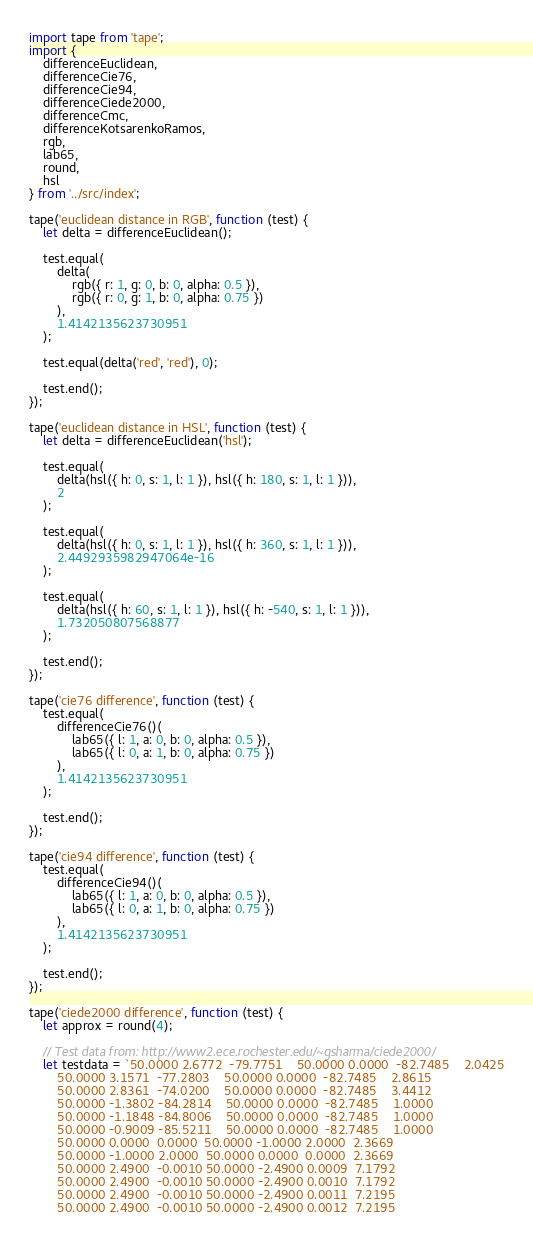Convert code to text. <code><loc_0><loc_0><loc_500><loc_500><_JavaScript_>import tape from 'tape';
import {
	differenceEuclidean,
	differenceCie76,
	differenceCie94,
	differenceCiede2000,
	differenceCmc,
	differenceKotsarenkoRamos,
	rgb,
	lab65,
	round,
	hsl
} from '../src/index';

tape('euclidean distance in RGB', function (test) {
	let delta = differenceEuclidean();

	test.equal(
		delta(
			rgb({ r: 1, g: 0, b: 0, alpha: 0.5 }),
			rgb({ r: 0, g: 1, b: 0, alpha: 0.75 })
		),
		1.4142135623730951
	);

	test.equal(delta('red', 'red'), 0);

	test.end();
});

tape('euclidean distance in HSL', function (test) {
	let delta = differenceEuclidean('hsl');

	test.equal(
		delta(hsl({ h: 0, s: 1, l: 1 }), hsl({ h: 180, s: 1, l: 1 })),
		2
	);

	test.equal(
		delta(hsl({ h: 0, s: 1, l: 1 }), hsl({ h: 360, s: 1, l: 1 })),
		2.4492935982947064e-16
	);

	test.equal(
		delta(hsl({ h: 60, s: 1, l: 1 }), hsl({ h: -540, s: 1, l: 1 })),
		1.732050807568877
	);

	test.end();
});

tape('cie76 difference', function (test) {
	test.equal(
		differenceCie76()(
			lab65({ l: 1, a: 0, b: 0, alpha: 0.5 }),
			lab65({ l: 0, a: 1, b: 0, alpha: 0.75 })
		),
		1.4142135623730951
	);

	test.end();
});

tape('cie94 difference', function (test) {
	test.equal(
		differenceCie94()(
			lab65({ l: 1, a: 0, b: 0, alpha: 0.5 }),
			lab65({ l: 0, a: 1, b: 0, alpha: 0.75 })
		),
		1.4142135623730951
	);

	test.end();
});

tape('ciede2000 difference', function (test) {
	let approx = round(4);

	// Test data from: http://www2.ece.rochester.edu/~gsharma/ciede2000/
	let testdata = `50.0000	2.6772	-79.7751	50.0000	0.0000	-82.7485	2.0425
		50.0000	3.1571	-77.2803	50.0000	0.0000	-82.7485	2.8615
		50.0000	2.8361	-74.0200	50.0000	0.0000	-82.7485	3.4412
		50.0000	-1.3802	-84.2814	50.0000	0.0000	-82.7485	1.0000
		50.0000	-1.1848	-84.8006	50.0000	0.0000	-82.7485	1.0000
		50.0000	-0.9009	-85.5211	50.0000	0.0000	-82.7485	1.0000
		50.0000	0.0000	0.0000	50.0000	-1.0000	2.0000	2.3669
		50.0000	-1.0000	2.0000	50.0000	0.0000	0.0000	2.3669
		50.0000	2.4900	-0.0010	50.0000	-2.4900	0.0009	7.1792
		50.0000	2.4900	-0.0010	50.0000	-2.4900	0.0010	7.1792
		50.0000	2.4900	-0.0010	50.0000	-2.4900	0.0011	7.2195
		50.0000	2.4900	-0.0010	50.0000	-2.4900	0.0012	7.2195</code> 